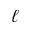Convert formula to latex. <formula><loc_0><loc_0><loc_500><loc_500>\ell</formula> 